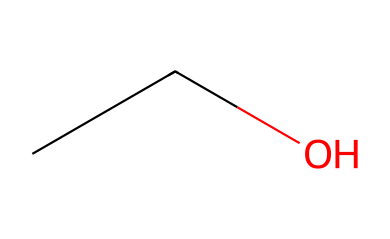how many carbon atoms are in ethanol? The SMILES representation "CCO" indicates there are two carbon atoms (C) in the structure as each 'C' represents a carbon atom.
Answer: 2 how many hydrogen atoms are in ethanol? In the SMILES "CCO," each carbon typically forms four bonds. The two carbon atoms are fully saturated with hydrogen, contributing a total of six hydrogen atoms (H) in the formula C2H6O.
Answer: 6 what is the functional group of ethanol? Ethanol contains a hydroxyl group (-OH), which is characteristic of alcohols. This can be identified in the SMILES by the "O" at the end of the representation, indicating a bond to hydrogen.
Answer: hydroxyl is ethanol polar or nonpolar? The presence of the hydroxyl group contributes to ethanol being polar due to the difference in electronegativity between oxygen and hydrogen. The molecule also has a hydrophilic region.
Answer: polar what is the boiling point of ethanol? Ethanol has a boiling point of approximately 78 degrees Celsius, which is characteristic for alcohols and influenced by its molecular structure and intermolecular hydrogen bonding.
Answer: 78 how does the structure of ethanol affect its solubility in water? The hydroxyl group allows ethanol to form hydrogen bonds with water molecules, enhancing its solubility in water. The polar nature of ethanol interacts favorably with water’s polar molecules.
Answer: enhances solubility what type of intermolecular forces are present in ethanol? Ethanol exhibits hydrogen bonding due to the presence of the hydroxyl group, as well as dipole-dipole interactions owing to its polar nature. These forces are significant in determining its properties.
Answer: hydrogen bonding 